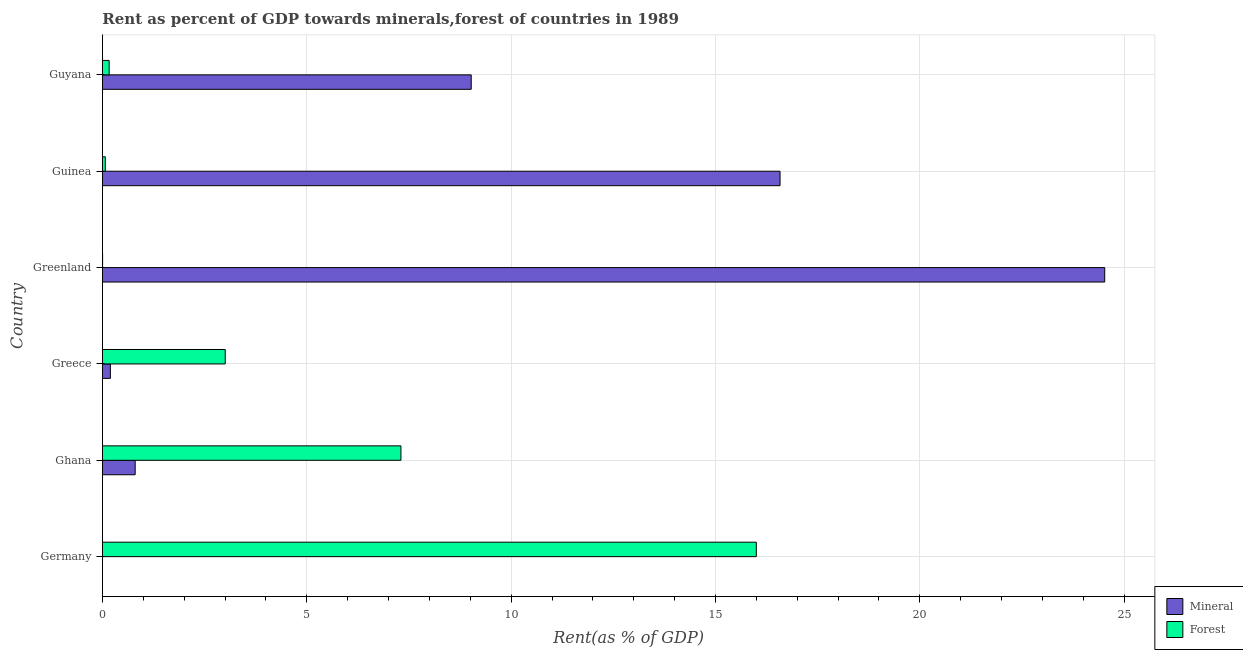How many different coloured bars are there?
Ensure brevity in your answer.  2. Are the number of bars on each tick of the Y-axis equal?
Your response must be concise. Yes. How many bars are there on the 6th tick from the bottom?
Provide a succinct answer. 2. What is the mineral rent in Greenland?
Your response must be concise. 24.52. Across all countries, what is the maximum forest rent?
Provide a succinct answer. 16. Across all countries, what is the minimum mineral rent?
Offer a very short reply. 0. In which country was the mineral rent maximum?
Offer a terse response. Greenland. What is the total forest rent in the graph?
Ensure brevity in your answer.  26.55. What is the difference between the forest rent in Germany and that in Guyana?
Your answer should be compact. 15.84. What is the difference between the mineral rent in Ghana and the forest rent in Greece?
Your answer should be very brief. -2.2. What is the average forest rent per country?
Make the answer very short. 4.42. What is the difference between the mineral rent and forest rent in Guyana?
Your answer should be very brief. 8.86. What is the ratio of the mineral rent in Greece to that in Guyana?
Offer a terse response. 0.02. Is the mineral rent in Ghana less than that in Greenland?
Your answer should be compact. Yes. What is the difference between the highest and the second highest forest rent?
Give a very brief answer. 8.7. What is the difference between the highest and the lowest mineral rent?
Offer a very short reply. 24.52. In how many countries, is the forest rent greater than the average forest rent taken over all countries?
Ensure brevity in your answer.  2. What does the 1st bar from the top in Ghana represents?
Offer a terse response. Forest. What does the 2nd bar from the bottom in Guinea represents?
Provide a succinct answer. Forest. What is the difference between two consecutive major ticks on the X-axis?
Provide a succinct answer. 5. Are the values on the major ticks of X-axis written in scientific E-notation?
Your response must be concise. No. Does the graph contain any zero values?
Your answer should be compact. No. Where does the legend appear in the graph?
Your response must be concise. Bottom right. How are the legend labels stacked?
Your answer should be compact. Vertical. What is the title of the graph?
Keep it short and to the point. Rent as percent of GDP towards minerals,forest of countries in 1989. Does "Nonresident" appear as one of the legend labels in the graph?
Your answer should be compact. No. What is the label or title of the X-axis?
Offer a very short reply. Rent(as % of GDP). What is the label or title of the Y-axis?
Your answer should be very brief. Country. What is the Rent(as % of GDP) of Mineral in Germany?
Ensure brevity in your answer.  0. What is the Rent(as % of GDP) of Forest in Germany?
Offer a very short reply. 16. What is the Rent(as % of GDP) of Mineral in Ghana?
Keep it short and to the point. 0.8. What is the Rent(as % of GDP) of Forest in Ghana?
Keep it short and to the point. 7.3. What is the Rent(as % of GDP) of Mineral in Greece?
Keep it short and to the point. 0.19. What is the Rent(as % of GDP) in Forest in Greece?
Your response must be concise. 3. What is the Rent(as % of GDP) in Mineral in Greenland?
Keep it short and to the point. 24.52. What is the Rent(as % of GDP) in Forest in Greenland?
Make the answer very short. 0. What is the Rent(as % of GDP) in Mineral in Guinea?
Provide a succinct answer. 16.58. What is the Rent(as % of GDP) of Forest in Guinea?
Offer a very short reply. 0.07. What is the Rent(as % of GDP) of Mineral in Guyana?
Provide a succinct answer. 9.02. What is the Rent(as % of GDP) in Forest in Guyana?
Your answer should be very brief. 0.16. Across all countries, what is the maximum Rent(as % of GDP) of Mineral?
Make the answer very short. 24.52. Across all countries, what is the maximum Rent(as % of GDP) in Forest?
Keep it short and to the point. 16. Across all countries, what is the minimum Rent(as % of GDP) in Mineral?
Your answer should be compact. 0. Across all countries, what is the minimum Rent(as % of GDP) of Forest?
Offer a very short reply. 0. What is the total Rent(as % of GDP) in Mineral in the graph?
Offer a terse response. 51.12. What is the total Rent(as % of GDP) of Forest in the graph?
Your response must be concise. 26.55. What is the difference between the Rent(as % of GDP) in Mineral in Germany and that in Ghana?
Ensure brevity in your answer.  -0.8. What is the difference between the Rent(as % of GDP) in Forest in Germany and that in Ghana?
Offer a terse response. 8.7. What is the difference between the Rent(as % of GDP) in Mineral in Germany and that in Greece?
Make the answer very short. -0.19. What is the difference between the Rent(as % of GDP) of Forest in Germany and that in Greece?
Offer a terse response. 13. What is the difference between the Rent(as % of GDP) in Mineral in Germany and that in Greenland?
Give a very brief answer. -24.52. What is the difference between the Rent(as % of GDP) in Forest in Germany and that in Greenland?
Keep it short and to the point. 16. What is the difference between the Rent(as % of GDP) in Mineral in Germany and that in Guinea?
Offer a terse response. -16.58. What is the difference between the Rent(as % of GDP) in Forest in Germany and that in Guinea?
Keep it short and to the point. 15.93. What is the difference between the Rent(as % of GDP) in Mineral in Germany and that in Guyana?
Your answer should be compact. -9.02. What is the difference between the Rent(as % of GDP) of Forest in Germany and that in Guyana?
Give a very brief answer. 15.84. What is the difference between the Rent(as % of GDP) in Mineral in Ghana and that in Greece?
Provide a short and direct response. 0.61. What is the difference between the Rent(as % of GDP) of Forest in Ghana and that in Greece?
Offer a terse response. 4.3. What is the difference between the Rent(as % of GDP) of Mineral in Ghana and that in Greenland?
Provide a succinct answer. -23.72. What is the difference between the Rent(as % of GDP) in Forest in Ghana and that in Greenland?
Provide a succinct answer. 7.3. What is the difference between the Rent(as % of GDP) of Mineral in Ghana and that in Guinea?
Provide a short and direct response. -15.78. What is the difference between the Rent(as % of GDP) in Forest in Ghana and that in Guinea?
Your answer should be compact. 7.23. What is the difference between the Rent(as % of GDP) of Mineral in Ghana and that in Guyana?
Keep it short and to the point. -8.22. What is the difference between the Rent(as % of GDP) of Forest in Ghana and that in Guyana?
Ensure brevity in your answer.  7.14. What is the difference between the Rent(as % of GDP) of Mineral in Greece and that in Greenland?
Your response must be concise. -24.33. What is the difference between the Rent(as % of GDP) in Forest in Greece and that in Greenland?
Offer a terse response. 3. What is the difference between the Rent(as % of GDP) in Mineral in Greece and that in Guinea?
Provide a short and direct response. -16.39. What is the difference between the Rent(as % of GDP) in Forest in Greece and that in Guinea?
Your answer should be compact. 2.93. What is the difference between the Rent(as % of GDP) in Mineral in Greece and that in Guyana?
Offer a very short reply. -8.83. What is the difference between the Rent(as % of GDP) in Forest in Greece and that in Guyana?
Offer a terse response. 2.84. What is the difference between the Rent(as % of GDP) of Mineral in Greenland and that in Guinea?
Offer a very short reply. 7.94. What is the difference between the Rent(as % of GDP) of Forest in Greenland and that in Guinea?
Offer a very short reply. -0.07. What is the difference between the Rent(as % of GDP) of Mineral in Greenland and that in Guyana?
Offer a terse response. 15.5. What is the difference between the Rent(as % of GDP) in Forest in Greenland and that in Guyana?
Your response must be concise. -0.16. What is the difference between the Rent(as % of GDP) of Mineral in Guinea and that in Guyana?
Offer a very short reply. 7.56. What is the difference between the Rent(as % of GDP) of Forest in Guinea and that in Guyana?
Your answer should be very brief. -0.09. What is the difference between the Rent(as % of GDP) of Mineral in Germany and the Rent(as % of GDP) of Forest in Ghana?
Give a very brief answer. -7.3. What is the difference between the Rent(as % of GDP) in Mineral in Germany and the Rent(as % of GDP) in Forest in Greece?
Your answer should be compact. -3. What is the difference between the Rent(as % of GDP) in Mineral in Germany and the Rent(as % of GDP) in Forest in Greenland?
Your answer should be very brief. -0. What is the difference between the Rent(as % of GDP) of Mineral in Germany and the Rent(as % of GDP) of Forest in Guinea?
Provide a short and direct response. -0.07. What is the difference between the Rent(as % of GDP) in Mineral in Germany and the Rent(as % of GDP) in Forest in Guyana?
Offer a very short reply. -0.16. What is the difference between the Rent(as % of GDP) of Mineral in Ghana and the Rent(as % of GDP) of Forest in Greece?
Offer a very short reply. -2.2. What is the difference between the Rent(as % of GDP) of Mineral in Ghana and the Rent(as % of GDP) of Forest in Greenland?
Ensure brevity in your answer.  0.8. What is the difference between the Rent(as % of GDP) of Mineral in Ghana and the Rent(as % of GDP) of Forest in Guinea?
Keep it short and to the point. 0.73. What is the difference between the Rent(as % of GDP) of Mineral in Ghana and the Rent(as % of GDP) of Forest in Guyana?
Provide a succinct answer. 0.64. What is the difference between the Rent(as % of GDP) of Mineral in Greece and the Rent(as % of GDP) of Forest in Greenland?
Offer a terse response. 0.19. What is the difference between the Rent(as % of GDP) in Mineral in Greece and the Rent(as % of GDP) in Forest in Guinea?
Offer a very short reply. 0.12. What is the difference between the Rent(as % of GDP) in Mineral in Greece and the Rent(as % of GDP) in Forest in Guyana?
Your answer should be compact. 0.03. What is the difference between the Rent(as % of GDP) in Mineral in Greenland and the Rent(as % of GDP) in Forest in Guinea?
Offer a very short reply. 24.45. What is the difference between the Rent(as % of GDP) of Mineral in Greenland and the Rent(as % of GDP) of Forest in Guyana?
Offer a very short reply. 24.36. What is the difference between the Rent(as % of GDP) of Mineral in Guinea and the Rent(as % of GDP) of Forest in Guyana?
Offer a very short reply. 16.42. What is the average Rent(as % of GDP) of Mineral per country?
Provide a succinct answer. 8.52. What is the average Rent(as % of GDP) in Forest per country?
Your answer should be very brief. 4.42. What is the difference between the Rent(as % of GDP) in Mineral and Rent(as % of GDP) in Forest in Germany?
Give a very brief answer. -16. What is the difference between the Rent(as % of GDP) of Mineral and Rent(as % of GDP) of Forest in Ghana?
Ensure brevity in your answer.  -6.5. What is the difference between the Rent(as % of GDP) in Mineral and Rent(as % of GDP) in Forest in Greece?
Provide a succinct answer. -2.81. What is the difference between the Rent(as % of GDP) of Mineral and Rent(as % of GDP) of Forest in Greenland?
Provide a succinct answer. 24.52. What is the difference between the Rent(as % of GDP) in Mineral and Rent(as % of GDP) in Forest in Guinea?
Your answer should be compact. 16.51. What is the difference between the Rent(as % of GDP) of Mineral and Rent(as % of GDP) of Forest in Guyana?
Ensure brevity in your answer.  8.86. What is the ratio of the Rent(as % of GDP) of Mineral in Germany to that in Ghana?
Provide a succinct answer. 0. What is the ratio of the Rent(as % of GDP) in Forest in Germany to that in Ghana?
Give a very brief answer. 2.19. What is the ratio of the Rent(as % of GDP) in Mineral in Germany to that in Greece?
Make the answer very short. 0. What is the ratio of the Rent(as % of GDP) of Forest in Germany to that in Greece?
Keep it short and to the point. 5.33. What is the ratio of the Rent(as % of GDP) of Forest in Germany to that in Greenland?
Your response must be concise. 4606.18. What is the ratio of the Rent(as % of GDP) of Forest in Germany to that in Guinea?
Your answer should be very brief. 227.45. What is the ratio of the Rent(as % of GDP) of Mineral in Germany to that in Guyana?
Provide a short and direct response. 0. What is the ratio of the Rent(as % of GDP) in Forest in Germany to that in Guyana?
Ensure brevity in your answer.  97.76. What is the ratio of the Rent(as % of GDP) of Mineral in Ghana to that in Greece?
Keep it short and to the point. 4.13. What is the ratio of the Rent(as % of GDP) of Forest in Ghana to that in Greece?
Provide a succinct answer. 2.43. What is the ratio of the Rent(as % of GDP) in Mineral in Ghana to that in Greenland?
Make the answer very short. 0.03. What is the ratio of the Rent(as % of GDP) in Forest in Ghana to that in Greenland?
Ensure brevity in your answer.  2102.63. What is the ratio of the Rent(as % of GDP) of Mineral in Ghana to that in Guinea?
Your response must be concise. 0.05. What is the ratio of the Rent(as % of GDP) in Forest in Ghana to that in Guinea?
Provide a succinct answer. 103.83. What is the ratio of the Rent(as % of GDP) in Mineral in Ghana to that in Guyana?
Offer a terse response. 0.09. What is the ratio of the Rent(as % of GDP) in Forest in Ghana to that in Guyana?
Give a very brief answer. 44.62. What is the ratio of the Rent(as % of GDP) of Mineral in Greece to that in Greenland?
Offer a terse response. 0.01. What is the ratio of the Rent(as % of GDP) of Forest in Greece to that in Greenland?
Provide a succinct answer. 864.97. What is the ratio of the Rent(as % of GDP) of Mineral in Greece to that in Guinea?
Your answer should be compact. 0.01. What is the ratio of the Rent(as % of GDP) of Forest in Greece to that in Guinea?
Provide a short and direct response. 42.71. What is the ratio of the Rent(as % of GDP) in Mineral in Greece to that in Guyana?
Make the answer very short. 0.02. What is the ratio of the Rent(as % of GDP) in Forest in Greece to that in Guyana?
Keep it short and to the point. 18.36. What is the ratio of the Rent(as % of GDP) of Mineral in Greenland to that in Guinea?
Give a very brief answer. 1.48. What is the ratio of the Rent(as % of GDP) of Forest in Greenland to that in Guinea?
Your answer should be very brief. 0.05. What is the ratio of the Rent(as % of GDP) in Mineral in Greenland to that in Guyana?
Your response must be concise. 2.72. What is the ratio of the Rent(as % of GDP) in Forest in Greenland to that in Guyana?
Offer a terse response. 0.02. What is the ratio of the Rent(as % of GDP) in Mineral in Guinea to that in Guyana?
Make the answer very short. 1.84. What is the ratio of the Rent(as % of GDP) in Forest in Guinea to that in Guyana?
Make the answer very short. 0.43. What is the difference between the highest and the second highest Rent(as % of GDP) of Mineral?
Give a very brief answer. 7.94. What is the difference between the highest and the second highest Rent(as % of GDP) of Forest?
Ensure brevity in your answer.  8.7. What is the difference between the highest and the lowest Rent(as % of GDP) of Mineral?
Your answer should be very brief. 24.52. What is the difference between the highest and the lowest Rent(as % of GDP) in Forest?
Provide a short and direct response. 16. 